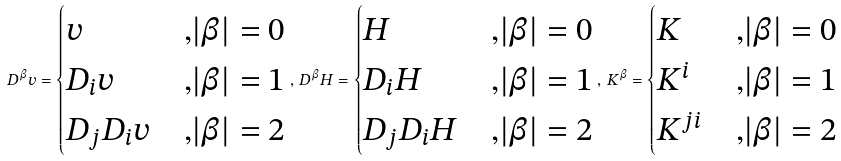<formula> <loc_0><loc_0><loc_500><loc_500>D ^ { \beta } v = \begin{cases} v & { , } | \beta | = 0 \\ D _ { i } v & { , } | \beta | = 1 \\ D _ { j } D _ { i } v & { , } | \beta | = 2 \end{cases} , \, D ^ { \beta } H = \begin{cases} H & { , } | \beta | = 0 \\ D _ { i } H & { , } | \beta | = 1 \\ D _ { j } D _ { i } H & { , } | \beta | = 2 \end{cases} , \, K ^ { \beta } = \begin{cases} K & { , } | \beta | = 0 \\ K ^ { i } & { , } | \beta | = 1 \\ K ^ { j i } & { , } | \beta | = 2 \end{cases}</formula> 